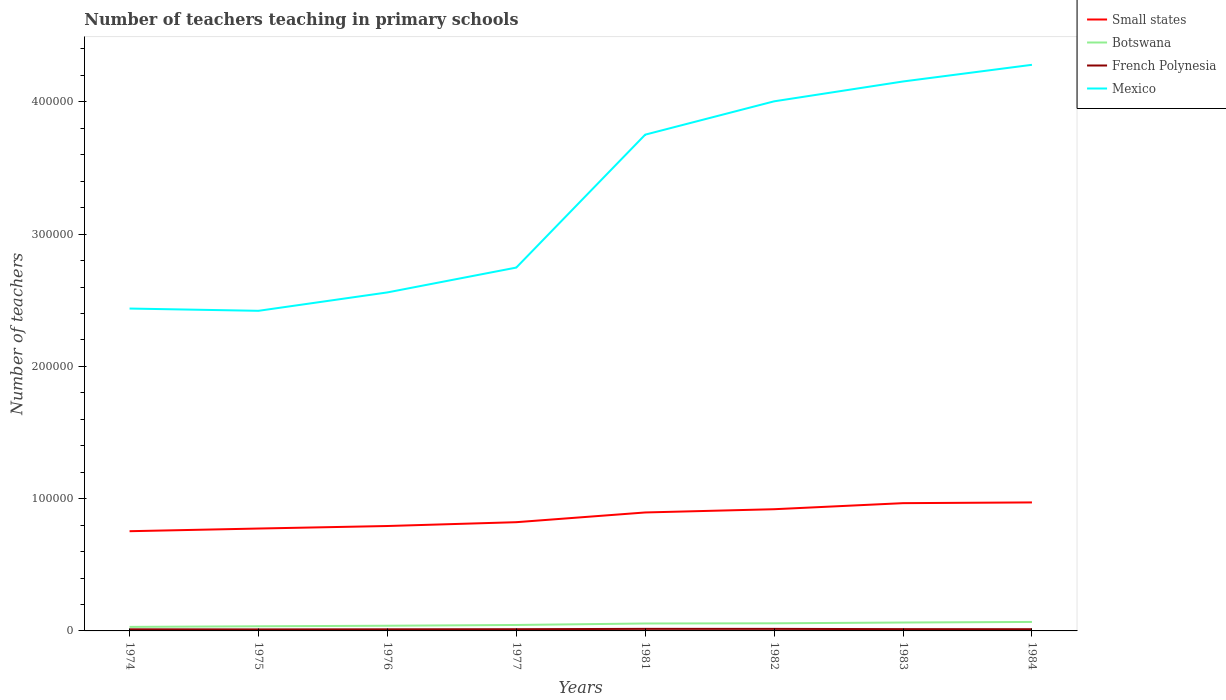How many different coloured lines are there?
Keep it short and to the point. 4. Does the line corresponding to Small states intersect with the line corresponding to Botswana?
Ensure brevity in your answer.  No. Is the number of lines equal to the number of legend labels?
Your answer should be compact. Yes. Across all years, what is the maximum number of teachers teaching in primary schools in Botswana?
Ensure brevity in your answer.  3047. In which year was the number of teachers teaching in primary schools in Mexico maximum?
Make the answer very short. 1975. What is the total number of teachers teaching in primary schools in Botswana in the graph?
Keep it short and to the point. -3285. What is the difference between the highest and the second highest number of teachers teaching in primary schools in Botswana?
Offer a terse response. 3747. What is the difference between the highest and the lowest number of teachers teaching in primary schools in Botswana?
Give a very brief answer. 4. Is the number of teachers teaching in primary schools in Small states strictly greater than the number of teachers teaching in primary schools in Mexico over the years?
Give a very brief answer. Yes. How many lines are there?
Give a very brief answer. 4. How are the legend labels stacked?
Offer a terse response. Vertical. What is the title of the graph?
Offer a very short reply. Number of teachers teaching in primary schools. Does "Cuba" appear as one of the legend labels in the graph?
Offer a terse response. No. What is the label or title of the Y-axis?
Ensure brevity in your answer.  Number of teachers. What is the Number of teachers of Small states in 1974?
Your answer should be very brief. 7.54e+04. What is the Number of teachers of Botswana in 1974?
Keep it short and to the point. 3047. What is the Number of teachers in French Polynesia in 1974?
Provide a succinct answer. 1213. What is the Number of teachers of Mexico in 1974?
Provide a short and direct response. 2.44e+05. What is the Number of teachers of Small states in 1975?
Offer a terse response. 7.74e+04. What is the Number of teachers of Botswana in 1975?
Provide a short and direct response. 3509. What is the Number of teachers of French Polynesia in 1975?
Offer a terse response. 1149. What is the Number of teachers of Mexico in 1975?
Provide a succinct answer. 2.42e+05. What is the Number of teachers in Small states in 1976?
Provide a short and direct response. 7.93e+04. What is the Number of teachers of Botswana in 1976?
Provide a succinct answer. 3921. What is the Number of teachers in French Polynesia in 1976?
Ensure brevity in your answer.  1213. What is the Number of teachers of Mexico in 1976?
Offer a terse response. 2.56e+05. What is the Number of teachers of Small states in 1977?
Offer a terse response. 8.22e+04. What is the Number of teachers in Botswana in 1977?
Offer a very short reply. 4495. What is the Number of teachers of French Polynesia in 1977?
Offer a terse response. 1295. What is the Number of teachers of Mexico in 1977?
Provide a succinct answer. 2.75e+05. What is the Number of teachers in Small states in 1981?
Keep it short and to the point. 8.96e+04. What is the Number of teachers of Botswana in 1981?
Your response must be concise. 5628. What is the Number of teachers of French Polynesia in 1981?
Provide a succinct answer. 1556. What is the Number of teachers in Mexico in 1981?
Your answer should be compact. 3.75e+05. What is the Number of teachers of Small states in 1982?
Keep it short and to the point. 9.20e+04. What is the Number of teachers in Botswana in 1982?
Offer a terse response. 5767. What is the Number of teachers in French Polynesia in 1982?
Keep it short and to the point. 1544. What is the Number of teachers of Mexico in 1982?
Offer a terse response. 4.00e+05. What is the Number of teachers of Small states in 1983?
Keep it short and to the point. 9.66e+04. What is the Number of teachers of Botswana in 1983?
Offer a very short reply. 6360. What is the Number of teachers of French Polynesia in 1983?
Your answer should be compact. 1361. What is the Number of teachers in Mexico in 1983?
Your answer should be compact. 4.15e+05. What is the Number of teachers in Small states in 1984?
Offer a very short reply. 9.72e+04. What is the Number of teachers in Botswana in 1984?
Your answer should be very brief. 6794. What is the Number of teachers of French Polynesia in 1984?
Your answer should be compact. 1295. What is the Number of teachers in Mexico in 1984?
Your response must be concise. 4.28e+05. Across all years, what is the maximum Number of teachers of Small states?
Your answer should be very brief. 9.72e+04. Across all years, what is the maximum Number of teachers of Botswana?
Ensure brevity in your answer.  6794. Across all years, what is the maximum Number of teachers in French Polynesia?
Give a very brief answer. 1556. Across all years, what is the maximum Number of teachers of Mexico?
Offer a very short reply. 4.28e+05. Across all years, what is the minimum Number of teachers in Small states?
Provide a succinct answer. 7.54e+04. Across all years, what is the minimum Number of teachers in Botswana?
Offer a terse response. 3047. Across all years, what is the minimum Number of teachers of French Polynesia?
Your response must be concise. 1149. Across all years, what is the minimum Number of teachers in Mexico?
Keep it short and to the point. 2.42e+05. What is the total Number of teachers of Small states in the graph?
Give a very brief answer. 6.90e+05. What is the total Number of teachers of Botswana in the graph?
Keep it short and to the point. 3.95e+04. What is the total Number of teachers in French Polynesia in the graph?
Your response must be concise. 1.06e+04. What is the total Number of teachers of Mexico in the graph?
Your response must be concise. 2.64e+06. What is the difference between the Number of teachers in Small states in 1974 and that in 1975?
Provide a succinct answer. -2020.26. What is the difference between the Number of teachers of Botswana in 1974 and that in 1975?
Your answer should be compact. -462. What is the difference between the Number of teachers in French Polynesia in 1974 and that in 1975?
Your answer should be very brief. 64. What is the difference between the Number of teachers of Mexico in 1974 and that in 1975?
Give a very brief answer. 1706. What is the difference between the Number of teachers of Small states in 1974 and that in 1976?
Provide a succinct answer. -3926.93. What is the difference between the Number of teachers of Botswana in 1974 and that in 1976?
Provide a succinct answer. -874. What is the difference between the Number of teachers in French Polynesia in 1974 and that in 1976?
Your response must be concise. 0. What is the difference between the Number of teachers of Mexico in 1974 and that in 1976?
Provide a short and direct response. -1.22e+04. What is the difference between the Number of teachers of Small states in 1974 and that in 1977?
Offer a very short reply. -6812.93. What is the difference between the Number of teachers of Botswana in 1974 and that in 1977?
Your answer should be very brief. -1448. What is the difference between the Number of teachers in French Polynesia in 1974 and that in 1977?
Your answer should be very brief. -82. What is the difference between the Number of teachers in Mexico in 1974 and that in 1977?
Make the answer very short. -3.10e+04. What is the difference between the Number of teachers of Small states in 1974 and that in 1981?
Your answer should be compact. -1.42e+04. What is the difference between the Number of teachers of Botswana in 1974 and that in 1981?
Offer a terse response. -2581. What is the difference between the Number of teachers of French Polynesia in 1974 and that in 1981?
Make the answer very short. -343. What is the difference between the Number of teachers in Mexico in 1974 and that in 1981?
Keep it short and to the point. -1.31e+05. What is the difference between the Number of teachers in Small states in 1974 and that in 1982?
Provide a short and direct response. -1.66e+04. What is the difference between the Number of teachers in Botswana in 1974 and that in 1982?
Offer a terse response. -2720. What is the difference between the Number of teachers of French Polynesia in 1974 and that in 1982?
Your response must be concise. -331. What is the difference between the Number of teachers of Mexico in 1974 and that in 1982?
Your answer should be very brief. -1.57e+05. What is the difference between the Number of teachers in Small states in 1974 and that in 1983?
Your answer should be compact. -2.12e+04. What is the difference between the Number of teachers of Botswana in 1974 and that in 1983?
Offer a terse response. -3313. What is the difference between the Number of teachers in French Polynesia in 1974 and that in 1983?
Ensure brevity in your answer.  -148. What is the difference between the Number of teachers in Mexico in 1974 and that in 1983?
Give a very brief answer. -1.72e+05. What is the difference between the Number of teachers of Small states in 1974 and that in 1984?
Give a very brief answer. -2.18e+04. What is the difference between the Number of teachers in Botswana in 1974 and that in 1984?
Provide a short and direct response. -3747. What is the difference between the Number of teachers of French Polynesia in 1974 and that in 1984?
Give a very brief answer. -82. What is the difference between the Number of teachers in Mexico in 1974 and that in 1984?
Ensure brevity in your answer.  -1.84e+05. What is the difference between the Number of teachers of Small states in 1975 and that in 1976?
Offer a terse response. -1906.67. What is the difference between the Number of teachers in Botswana in 1975 and that in 1976?
Ensure brevity in your answer.  -412. What is the difference between the Number of teachers of French Polynesia in 1975 and that in 1976?
Offer a terse response. -64. What is the difference between the Number of teachers in Mexico in 1975 and that in 1976?
Your answer should be very brief. -1.39e+04. What is the difference between the Number of teachers in Small states in 1975 and that in 1977?
Keep it short and to the point. -4792.67. What is the difference between the Number of teachers of Botswana in 1975 and that in 1977?
Your answer should be very brief. -986. What is the difference between the Number of teachers in French Polynesia in 1975 and that in 1977?
Your answer should be very brief. -146. What is the difference between the Number of teachers in Mexico in 1975 and that in 1977?
Ensure brevity in your answer.  -3.27e+04. What is the difference between the Number of teachers in Small states in 1975 and that in 1981?
Offer a terse response. -1.21e+04. What is the difference between the Number of teachers in Botswana in 1975 and that in 1981?
Provide a succinct answer. -2119. What is the difference between the Number of teachers in French Polynesia in 1975 and that in 1981?
Offer a very short reply. -407. What is the difference between the Number of teachers of Mexico in 1975 and that in 1981?
Offer a terse response. -1.33e+05. What is the difference between the Number of teachers of Small states in 1975 and that in 1982?
Give a very brief answer. -1.46e+04. What is the difference between the Number of teachers of Botswana in 1975 and that in 1982?
Provide a succinct answer. -2258. What is the difference between the Number of teachers in French Polynesia in 1975 and that in 1982?
Keep it short and to the point. -395. What is the difference between the Number of teachers of Mexico in 1975 and that in 1982?
Keep it short and to the point. -1.58e+05. What is the difference between the Number of teachers in Small states in 1975 and that in 1983?
Give a very brief answer. -1.92e+04. What is the difference between the Number of teachers in Botswana in 1975 and that in 1983?
Offer a terse response. -2851. What is the difference between the Number of teachers in French Polynesia in 1975 and that in 1983?
Your response must be concise. -212. What is the difference between the Number of teachers of Mexico in 1975 and that in 1983?
Your answer should be compact. -1.73e+05. What is the difference between the Number of teachers of Small states in 1975 and that in 1984?
Your response must be concise. -1.97e+04. What is the difference between the Number of teachers of Botswana in 1975 and that in 1984?
Offer a terse response. -3285. What is the difference between the Number of teachers of French Polynesia in 1975 and that in 1984?
Make the answer very short. -146. What is the difference between the Number of teachers of Mexico in 1975 and that in 1984?
Ensure brevity in your answer.  -1.86e+05. What is the difference between the Number of teachers in Small states in 1976 and that in 1977?
Provide a succinct answer. -2886. What is the difference between the Number of teachers in Botswana in 1976 and that in 1977?
Provide a succinct answer. -574. What is the difference between the Number of teachers in French Polynesia in 1976 and that in 1977?
Provide a short and direct response. -82. What is the difference between the Number of teachers of Mexico in 1976 and that in 1977?
Provide a short and direct response. -1.88e+04. What is the difference between the Number of teachers of Small states in 1976 and that in 1981?
Your response must be concise. -1.02e+04. What is the difference between the Number of teachers in Botswana in 1976 and that in 1981?
Ensure brevity in your answer.  -1707. What is the difference between the Number of teachers of French Polynesia in 1976 and that in 1981?
Provide a succinct answer. -343. What is the difference between the Number of teachers of Mexico in 1976 and that in 1981?
Provide a short and direct response. -1.19e+05. What is the difference between the Number of teachers of Small states in 1976 and that in 1982?
Offer a very short reply. -1.27e+04. What is the difference between the Number of teachers in Botswana in 1976 and that in 1982?
Offer a terse response. -1846. What is the difference between the Number of teachers of French Polynesia in 1976 and that in 1982?
Provide a short and direct response. -331. What is the difference between the Number of teachers of Mexico in 1976 and that in 1982?
Your answer should be compact. -1.44e+05. What is the difference between the Number of teachers of Small states in 1976 and that in 1983?
Keep it short and to the point. -1.73e+04. What is the difference between the Number of teachers in Botswana in 1976 and that in 1983?
Your answer should be compact. -2439. What is the difference between the Number of teachers of French Polynesia in 1976 and that in 1983?
Provide a short and direct response. -148. What is the difference between the Number of teachers in Mexico in 1976 and that in 1983?
Make the answer very short. -1.59e+05. What is the difference between the Number of teachers of Small states in 1976 and that in 1984?
Your response must be concise. -1.78e+04. What is the difference between the Number of teachers in Botswana in 1976 and that in 1984?
Offer a terse response. -2873. What is the difference between the Number of teachers in French Polynesia in 1976 and that in 1984?
Ensure brevity in your answer.  -82. What is the difference between the Number of teachers in Mexico in 1976 and that in 1984?
Keep it short and to the point. -1.72e+05. What is the difference between the Number of teachers in Small states in 1977 and that in 1981?
Ensure brevity in your answer.  -7356.84. What is the difference between the Number of teachers in Botswana in 1977 and that in 1981?
Offer a terse response. -1133. What is the difference between the Number of teachers in French Polynesia in 1977 and that in 1981?
Your response must be concise. -261. What is the difference between the Number of teachers of Mexico in 1977 and that in 1981?
Offer a terse response. -1.01e+05. What is the difference between the Number of teachers in Small states in 1977 and that in 1982?
Offer a terse response. -9806.43. What is the difference between the Number of teachers in Botswana in 1977 and that in 1982?
Provide a succinct answer. -1272. What is the difference between the Number of teachers in French Polynesia in 1977 and that in 1982?
Give a very brief answer. -249. What is the difference between the Number of teachers of Mexico in 1977 and that in 1982?
Your response must be concise. -1.26e+05. What is the difference between the Number of teachers of Small states in 1977 and that in 1983?
Make the answer very short. -1.44e+04. What is the difference between the Number of teachers in Botswana in 1977 and that in 1983?
Give a very brief answer. -1865. What is the difference between the Number of teachers of French Polynesia in 1977 and that in 1983?
Provide a short and direct response. -66. What is the difference between the Number of teachers in Mexico in 1977 and that in 1983?
Offer a very short reply. -1.41e+05. What is the difference between the Number of teachers of Small states in 1977 and that in 1984?
Give a very brief answer. -1.49e+04. What is the difference between the Number of teachers in Botswana in 1977 and that in 1984?
Offer a terse response. -2299. What is the difference between the Number of teachers in French Polynesia in 1977 and that in 1984?
Ensure brevity in your answer.  0. What is the difference between the Number of teachers of Mexico in 1977 and that in 1984?
Offer a very short reply. -1.53e+05. What is the difference between the Number of teachers of Small states in 1981 and that in 1982?
Give a very brief answer. -2449.59. What is the difference between the Number of teachers in Botswana in 1981 and that in 1982?
Provide a succinct answer. -139. What is the difference between the Number of teachers in Mexico in 1981 and that in 1982?
Your answer should be very brief. -2.52e+04. What is the difference between the Number of teachers of Small states in 1981 and that in 1983?
Give a very brief answer. -7031.91. What is the difference between the Number of teachers in Botswana in 1981 and that in 1983?
Provide a short and direct response. -732. What is the difference between the Number of teachers of French Polynesia in 1981 and that in 1983?
Keep it short and to the point. 195. What is the difference between the Number of teachers in Mexico in 1981 and that in 1983?
Make the answer very short. -4.02e+04. What is the difference between the Number of teachers in Small states in 1981 and that in 1984?
Your answer should be compact. -7590.36. What is the difference between the Number of teachers of Botswana in 1981 and that in 1984?
Your answer should be compact. -1166. What is the difference between the Number of teachers of French Polynesia in 1981 and that in 1984?
Provide a short and direct response. 261. What is the difference between the Number of teachers of Mexico in 1981 and that in 1984?
Keep it short and to the point. -5.28e+04. What is the difference between the Number of teachers in Small states in 1982 and that in 1983?
Offer a very short reply. -4582.32. What is the difference between the Number of teachers of Botswana in 1982 and that in 1983?
Keep it short and to the point. -593. What is the difference between the Number of teachers in French Polynesia in 1982 and that in 1983?
Give a very brief answer. 183. What is the difference between the Number of teachers in Mexico in 1982 and that in 1983?
Offer a very short reply. -1.50e+04. What is the difference between the Number of teachers of Small states in 1982 and that in 1984?
Offer a very short reply. -5140.77. What is the difference between the Number of teachers of Botswana in 1982 and that in 1984?
Your answer should be very brief. -1027. What is the difference between the Number of teachers of French Polynesia in 1982 and that in 1984?
Keep it short and to the point. 249. What is the difference between the Number of teachers in Mexico in 1982 and that in 1984?
Your answer should be compact. -2.76e+04. What is the difference between the Number of teachers in Small states in 1983 and that in 1984?
Provide a succinct answer. -558.45. What is the difference between the Number of teachers in Botswana in 1983 and that in 1984?
Offer a terse response. -434. What is the difference between the Number of teachers in French Polynesia in 1983 and that in 1984?
Your response must be concise. 66. What is the difference between the Number of teachers in Mexico in 1983 and that in 1984?
Provide a short and direct response. -1.26e+04. What is the difference between the Number of teachers in Small states in 1974 and the Number of teachers in Botswana in 1975?
Offer a very short reply. 7.19e+04. What is the difference between the Number of teachers in Small states in 1974 and the Number of teachers in French Polynesia in 1975?
Keep it short and to the point. 7.42e+04. What is the difference between the Number of teachers in Small states in 1974 and the Number of teachers in Mexico in 1975?
Give a very brief answer. -1.67e+05. What is the difference between the Number of teachers in Botswana in 1974 and the Number of teachers in French Polynesia in 1975?
Your answer should be very brief. 1898. What is the difference between the Number of teachers of Botswana in 1974 and the Number of teachers of Mexico in 1975?
Give a very brief answer. -2.39e+05. What is the difference between the Number of teachers of French Polynesia in 1974 and the Number of teachers of Mexico in 1975?
Provide a short and direct response. -2.41e+05. What is the difference between the Number of teachers in Small states in 1974 and the Number of teachers in Botswana in 1976?
Give a very brief answer. 7.15e+04. What is the difference between the Number of teachers of Small states in 1974 and the Number of teachers of French Polynesia in 1976?
Give a very brief answer. 7.42e+04. What is the difference between the Number of teachers of Small states in 1974 and the Number of teachers of Mexico in 1976?
Your response must be concise. -1.81e+05. What is the difference between the Number of teachers in Botswana in 1974 and the Number of teachers in French Polynesia in 1976?
Give a very brief answer. 1834. What is the difference between the Number of teachers of Botswana in 1974 and the Number of teachers of Mexico in 1976?
Make the answer very short. -2.53e+05. What is the difference between the Number of teachers in French Polynesia in 1974 and the Number of teachers in Mexico in 1976?
Give a very brief answer. -2.55e+05. What is the difference between the Number of teachers of Small states in 1974 and the Number of teachers of Botswana in 1977?
Make the answer very short. 7.09e+04. What is the difference between the Number of teachers in Small states in 1974 and the Number of teachers in French Polynesia in 1977?
Ensure brevity in your answer.  7.41e+04. What is the difference between the Number of teachers in Small states in 1974 and the Number of teachers in Mexico in 1977?
Ensure brevity in your answer.  -1.99e+05. What is the difference between the Number of teachers of Botswana in 1974 and the Number of teachers of French Polynesia in 1977?
Offer a terse response. 1752. What is the difference between the Number of teachers of Botswana in 1974 and the Number of teachers of Mexico in 1977?
Your answer should be very brief. -2.72e+05. What is the difference between the Number of teachers in French Polynesia in 1974 and the Number of teachers in Mexico in 1977?
Provide a succinct answer. -2.74e+05. What is the difference between the Number of teachers in Small states in 1974 and the Number of teachers in Botswana in 1981?
Offer a very short reply. 6.98e+04. What is the difference between the Number of teachers in Small states in 1974 and the Number of teachers in French Polynesia in 1981?
Offer a very short reply. 7.38e+04. What is the difference between the Number of teachers of Small states in 1974 and the Number of teachers of Mexico in 1981?
Your answer should be compact. -3.00e+05. What is the difference between the Number of teachers of Botswana in 1974 and the Number of teachers of French Polynesia in 1981?
Provide a succinct answer. 1491. What is the difference between the Number of teachers in Botswana in 1974 and the Number of teachers in Mexico in 1981?
Provide a short and direct response. -3.72e+05. What is the difference between the Number of teachers of French Polynesia in 1974 and the Number of teachers of Mexico in 1981?
Your response must be concise. -3.74e+05. What is the difference between the Number of teachers of Small states in 1974 and the Number of teachers of Botswana in 1982?
Your response must be concise. 6.96e+04. What is the difference between the Number of teachers of Small states in 1974 and the Number of teachers of French Polynesia in 1982?
Your answer should be compact. 7.39e+04. What is the difference between the Number of teachers in Small states in 1974 and the Number of teachers in Mexico in 1982?
Keep it short and to the point. -3.25e+05. What is the difference between the Number of teachers of Botswana in 1974 and the Number of teachers of French Polynesia in 1982?
Offer a terse response. 1503. What is the difference between the Number of teachers of Botswana in 1974 and the Number of teachers of Mexico in 1982?
Provide a succinct answer. -3.97e+05. What is the difference between the Number of teachers of French Polynesia in 1974 and the Number of teachers of Mexico in 1982?
Give a very brief answer. -3.99e+05. What is the difference between the Number of teachers of Small states in 1974 and the Number of teachers of Botswana in 1983?
Your answer should be compact. 6.90e+04. What is the difference between the Number of teachers in Small states in 1974 and the Number of teachers in French Polynesia in 1983?
Your answer should be compact. 7.40e+04. What is the difference between the Number of teachers of Small states in 1974 and the Number of teachers of Mexico in 1983?
Offer a terse response. -3.40e+05. What is the difference between the Number of teachers in Botswana in 1974 and the Number of teachers in French Polynesia in 1983?
Ensure brevity in your answer.  1686. What is the difference between the Number of teachers in Botswana in 1974 and the Number of teachers in Mexico in 1983?
Keep it short and to the point. -4.12e+05. What is the difference between the Number of teachers in French Polynesia in 1974 and the Number of teachers in Mexico in 1983?
Make the answer very short. -4.14e+05. What is the difference between the Number of teachers of Small states in 1974 and the Number of teachers of Botswana in 1984?
Your response must be concise. 6.86e+04. What is the difference between the Number of teachers in Small states in 1974 and the Number of teachers in French Polynesia in 1984?
Keep it short and to the point. 7.41e+04. What is the difference between the Number of teachers of Small states in 1974 and the Number of teachers of Mexico in 1984?
Ensure brevity in your answer.  -3.53e+05. What is the difference between the Number of teachers in Botswana in 1974 and the Number of teachers in French Polynesia in 1984?
Keep it short and to the point. 1752. What is the difference between the Number of teachers of Botswana in 1974 and the Number of teachers of Mexico in 1984?
Ensure brevity in your answer.  -4.25e+05. What is the difference between the Number of teachers in French Polynesia in 1974 and the Number of teachers in Mexico in 1984?
Provide a short and direct response. -4.27e+05. What is the difference between the Number of teachers in Small states in 1975 and the Number of teachers in Botswana in 1976?
Your answer should be compact. 7.35e+04. What is the difference between the Number of teachers in Small states in 1975 and the Number of teachers in French Polynesia in 1976?
Your answer should be compact. 7.62e+04. What is the difference between the Number of teachers in Small states in 1975 and the Number of teachers in Mexico in 1976?
Make the answer very short. -1.79e+05. What is the difference between the Number of teachers in Botswana in 1975 and the Number of teachers in French Polynesia in 1976?
Ensure brevity in your answer.  2296. What is the difference between the Number of teachers of Botswana in 1975 and the Number of teachers of Mexico in 1976?
Make the answer very short. -2.52e+05. What is the difference between the Number of teachers of French Polynesia in 1975 and the Number of teachers of Mexico in 1976?
Keep it short and to the point. -2.55e+05. What is the difference between the Number of teachers of Small states in 1975 and the Number of teachers of Botswana in 1977?
Offer a terse response. 7.29e+04. What is the difference between the Number of teachers in Small states in 1975 and the Number of teachers in French Polynesia in 1977?
Your response must be concise. 7.61e+04. What is the difference between the Number of teachers of Small states in 1975 and the Number of teachers of Mexico in 1977?
Offer a terse response. -1.97e+05. What is the difference between the Number of teachers of Botswana in 1975 and the Number of teachers of French Polynesia in 1977?
Your answer should be very brief. 2214. What is the difference between the Number of teachers of Botswana in 1975 and the Number of teachers of Mexico in 1977?
Make the answer very short. -2.71e+05. What is the difference between the Number of teachers of French Polynesia in 1975 and the Number of teachers of Mexico in 1977?
Ensure brevity in your answer.  -2.74e+05. What is the difference between the Number of teachers of Small states in 1975 and the Number of teachers of Botswana in 1981?
Offer a very short reply. 7.18e+04. What is the difference between the Number of teachers in Small states in 1975 and the Number of teachers in French Polynesia in 1981?
Your answer should be very brief. 7.59e+04. What is the difference between the Number of teachers in Small states in 1975 and the Number of teachers in Mexico in 1981?
Provide a succinct answer. -2.98e+05. What is the difference between the Number of teachers of Botswana in 1975 and the Number of teachers of French Polynesia in 1981?
Your answer should be very brief. 1953. What is the difference between the Number of teachers of Botswana in 1975 and the Number of teachers of Mexico in 1981?
Your answer should be compact. -3.72e+05. What is the difference between the Number of teachers of French Polynesia in 1975 and the Number of teachers of Mexico in 1981?
Your answer should be very brief. -3.74e+05. What is the difference between the Number of teachers of Small states in 1975 and the Number of teachers of Botswana in 1982?
Keep it short and to the point. 7.16e+04. What is the difference between the Number of teachers of Small states in 1975 and the Number of teachers of French Polynesia in 1982?
Your answer should be very brief. 7.59e+04. What is the difference between the Number of teachers in Small states in 1975 and the Number of teachers in Mexico in 1982?
Offer a very short reply. -3.23e+05. What is the difference between the Number of teachers of Botswana in 1975 and the Number of teachers of French Polynesia in 1982?
Provide a short and direct response. 1965. What is the difference between the Number of teachers of Botswana in 1975 and the Number of teachers of Mexico in 1982?
Offer a terse response. -3.97e+05. What is the difference between the Number of teachers of French Polynesia in 1975 and the Number of teachers of Mexico in 1982?
Your answer should be very brief. -3.99e+05. What is the difference between the Number of teachers of Small states in 1975 and the Number of teachers of Botswana in 1983?
Provide a short and direct response. 7.11e+04. What is the difference between the Number of teachers in Small states in 1975 and the Number of teachers in French Polynesia in 1983?
Make the answer very short. 7.61e+04. What is the difference between the Number of teachers of Small states in 1975 and the Number of teachers of Mexico in 1983?
Your response must be concise. -3.38e+05. What is the difference between the Number of teachers in Botswana in 1975 and the Number of teachers in French Polynesia in 1983?
Keep it short and to the point. 2148. What is the difference between the Number of teachers of Botswana in 1975 and the Number of teachers of Mexico in 1983?
Give a very brief answer. -4.12e+05. What is the difference between the Number of teachers in French Polynesia in 1975 and the Number of teachers in Mexico in 1983?
Keep it short and to the point. -4.14e+05. What is the difference between the Number of teachers of Small states in 1975 and the Number of teachers of Botswana in 1984?
Give a very brief answer. 7.06e+04. What is the difference between the Number of teachers of Small states in 1975 and the Number of teachers of French Polynesia in 1984?
Offer a terse response. 7.61e+04. What is the difference between the Number of teachers in Small states in 1975 and the Number of teachers in Mexico in 1984?
Offer a very short reply. -3.51e+05. What is the difference between the Number of teachers in Botswana in 1975 and the Number of teachers in French Polynesia in 1984?
Provide a short and direct response. 2214. What is the difference between the Number of teachers of Botswana in 1975 and the Number of teachers of Mexico in 1984?
Offer a very short reply. -4.25e+05. What is the difference between the Number of teachers of French Polynesia in 1975 and the Number of teachers of Mexico in 1984?
Offer a terse response. -4.27e+05. What is the difference between the Number of teachers of Small states in 1976 and the Number of teachers of Botswana in 1977?
Your answer should be very brief. 7.48e+04. What is the difference between the Number of teachers in Small states in 1976 and the Number of teachers in French Polynesia in 1977?
Offer a terse response. 7.80e+04. What is the difference between the Number of teachers in Small states in 1976 and the Number of teachers in Mexico in 1977?
Make the answer very short. -1.95e+05. What is the difference between the Number of teachers in Botswana in 1976 and the Number of teachers in French Polynesia in 1977?
Your response must be concise. 2626. What is the difference between the Number of teachers of Botswana in 1976 and the Number of teachers of Mexico in 1977?
Provide a short and direct response. -2.71e+05. What is the difference between the Number of teachers of French Polynesia in 1976 and the Number of teachers of Mexico in 1977?
Provide a short and direct response. -2.74e+05. What is the difference between the Number of teachers of Small states in 1976 and the Number of teachers of Botswana in 1981?
Provide a short and direct response. 7.37e+04. What is the difference between the Number of teachers in Small states in 1976 and the Number of teachers in French Polynesia in 1981?
Ensure brevity in your answer.  7.78e+04. What is the difference between the Number of teachers in Small states in 1976 and the Number of teachers in Mexico in 1981?
Keep it short and to the point. -2.96e+05. What is the difference between the Number of teachers of Botswana in 1976 and the Number of teachers of French Polynesia in 1981?
Your answer should be compact. 2365. What is the difference between the Number of teachers in Botswana in 1976 and the Number of teachers in Mexico in 1981?
Provide a succinct answer. -3.71e+05. What is the difference between the Number of teachers in French Polynesia in 1976 and the Number of teachers in Mexico in 1981?
Give a very brief answer. -3.74e+05. What is the difference between the Number of teachers of Small states in 1976 and the Number of teachers of Botswana in 1982?
Your response must be concise. 7.36e+04. What is the difference between the Number of teachers of Small states in 1976 and the Number of teachers of French Polynesia in 1982?
Offer a very short reply. 7.78e+04. What is the difference between the Number of teachers of Small states in 1976 and the Number of teachers of Mexico in 1982?
Offer a terse response. -3.21e+05. What is the difference between the Number of teachers in Botswana in 1976 and the Number of teachers in French Polynesia in 1982?
Your response must be concise. 2377. What is the difference between the Number of teachers in Botswana in 1976 and the Number of teachers in Mexico in 1982?
Offer a very short reply. -3.96e+05. What is the difference between the Number of teachers in French Polynesia in 1976 and the Number of teachers in Mexico in 1982?
Provide a short and direct response. -3.99e+05. What is the difference between the Number of teachers in Small states in 1976 and the Number of teachers in Botswana in 1983?
Give a very brief answer. 7.30e+04. What is the difference between the Number of teachers in Small states in 1976 and the Number of teachers in French Polynesia in 1983?
Give a very brief answer. 7.80e+04. What is the difference between the Number of teachers in Small states in 1976 and the Number of teachers in Mexico in 1983?
Your answer should be very brief. -3.36e+05. What is the difference between the Number of teachers in Botswana in 1976 and the Number of teachers in French Polynesia in 1983?
Offer a terse response. 2560. What is the difference between the Number of teachers in Botswana in 1976 and the Number of teachers in Mexico in 1983?
Your answer should be compact. -4.12e+05. What is the difference between the Number of teachers in French Polynesia in 1976 and the Number of teachers in Mexico in 1983?
Provide a short and direct response. -4.14e+05. What is the difference between the Number of teachers of Small states in 1976 and the Number of teachers of Botswana in 1984?
Provide a short and direct response. 7.25e+04. What is the difference between the Number of teachers in Small states in 1976 and the Number of teachers in French Polynesia in 1984?
Give a very brief answer. 7.80e+04. What is the difference between the Number of teachers in Small states in 1976 and the Number of teachers in Mexico in 1984?
Your response must be concise. -3.49e+05. What is the difference between the Number of teachers of Botswana in 1976 and the Number of teachers of French Polynesia in 1984?
Your answer should be compact. 2626. What is the difference between the Number of teachers in Botswana in 1976 and the Number of teachers in Mexico in 1984?
Offer a very short reply. -4.24e+05. What is the difference between the Number of teachers of French Polynesia in 1976 and the Number of teachers of Mexico in 1984?
Make the answer very short. -4.27e+05. What is the difference between the Number of teachers of Small states in 1977 and the Number of teachers of Botswana in 1981?
Keep it short and to the point. 7.66e+04. What is the difference between the Number of teachers in Small states in 1977 and the Number of teachers in French Polynesia in 1981?
Give a very brief answer. 8.07e+04. What is the difference between the Number of teachers of Small states in 1977 and the Number of teachers of Mexico in 1981?
Offer a very short reply. -2.93e+05. What is the difference between the Number of teachers of Botswana in 1977 and the Number of teachers of French Polynesia in 1981?
Your response must be concise. 2939. What is the difference between the Number of teachers in Botswana in 1977 and the Number of teachers in Mexico in 1981?
Keep it short and to the point. -3.71e+05. What is the difference between the Number of teachers of French Polynesia in 1977 and the Number of teachers of Mexico in 1981?
Ensure brevity in your answer.  -3.74e+05. What is the difference between the Number of teachers in Small states in 1977 and the Number of teachers in Botswana in 1982?
Your answer should be compact. 7.64e+04. What is the difference between the Number of teachers in Small states in 1977 and the Number of teachers in French Polynesia in 1982?
Make the answer very short. 8.07e+04. What is the difference between the Number of teachers of Small states in 1977 and the Number of teachers of Mexico in 1982?
Ensure brevity in your answer.  -3.18e+05. What is the difference between the Number of teachers of Botswana in 1977 and the Number of teachers of French Polynesia in 1982?
Provide a succinct answer. 2951. What is the difference between the Number of teachers in Botswana in 1977 and the Number of teachers in Mexico in 1982?
Provide a succinct answer. -3.96e+05. What is the difference between the Number of teachers in French Polynesia in 1977 and the Number of teachers in Mexico in 1982?
Your answer should be very brief. -3.99e+05. What is the difference between the Number of teachers of Small states in 1977 and the Number of teachers of Botswana in 1983?
Your answer should be very brief. 7.58e+04. What is the difference between the Number of teachers of Small states in 1977 and the Number of teachers of French Polynesia in 1983?
Provide a succinct answer. 8.08e+04. What is the difference between the Number of teachers of Small states in 1977 and the Number of teachers of Mexico in 1983?
Your response must be concise. -3.33e+05. What is the difference between the Number of teachers of Botswana in 1977 and the Number of teachers of French Polynesia in 1983?
Keep it short and to the point. 3134. What is the difference between the Number of teachers in Botswana in 1977 and the Number of teachers in Mexico in 1983?
Your response must be concise. -4.11e+05. What is the difference between the Number of teachers in French Polynesia in 1977 and the Number of teachers in Mexico in 1983?
Keep it short and to the point. -4.14e+05. What is the difference between the Number of teachers of Small states in 1977 and the Number of teachers of Botswana in 1984?
Offer a very short reply. 7.54e+04. What is the difference between the Number of teachers of Small states in 1977 and the Number of teachers of French Polynesia in 1984?
Provide a short and direct response. 8.09e+04. What is the difference between the Number of teachers in Small states in 1977 and the Number of teachers in Mexico in 1984?
Your answer should be very brief. -3.46e+05. What is the difference between the Number of teachers of Botswana in 1977 and the Number of teachers of French Polynesia in 1984?
Your response must be concise. 3200. What is the difference between the Number of teachers of Botswana in 1977 and the Number of teachers of Mexico in 1984?
Your answer should be compact. -4.24e+05. What is the difference between the Number of teachers in French Polynesia in 1977 and the Number of teachers in Mexico in 1984?
Keep it short and to the point. -4.27e+05. What is the difference between the Number of teachers in Small states in 1981 and the Number of teachers in Botswana in 1982?
Offer a very short reply. 8.38e+04. What is the difference between the Number of teachers of Small states in 1981 and the Number of teachers of French Polynesia in 1982?
Your response must be concise. 8.80e+04. What is the difference between the Number of teachers in Small states in 1981 and the Number of teachers in Mexico in 1982?
Provide a short and direct response. -3.11e+05. What is the difference between the Number of teachers of Botswana in 1981 and the Number of teachers of French Polynesia in 1982?
Your answer should be compact. 4084. What is the difference between the Number of teachers of Botswana in 1981 and the Number of teachers of Mexico in 1982?
Keep it short and to the point. -3.95e+05. What is the difference between the Number of teachers of French Polynesia in 1981 and the Number of teachers of Mexico in 1982?
Offer a terse response. -3.99e+05. What is the difference between the Number of teachers in Small states in 1981 and the Number of teachers in Botswana in 1983?
Make the answer very short. 8.32e+04. What is the difference between the Number of teachers in Small states in 1981 and the Number of teachers in French Polynesia in 1983?
Provide a short and direct response. 8.82e+04. What is the difference between the Number of teachers in Small states in 1981 and the Number of teachers in Mexico in 1983?
Provide a short and direct response. -3.26e+05. What is the difference between the Number of teachers of Botswana in 1981 and the Number of teachers of French Polynesia in 1983?
Your answer should be compact. 4267. What is the difference between the Number of teachers of Botswana in 1981 and the Number of teachers of Mexico in 1983?
Make the answer very short. -4.10e+05. What is the difference between the Number of teachers in French Polynesia in 1981 and the Number of teachers in Mexico in 1983?
Your answer should be very brief. -4.14e+05. What is the difference between the Number of teachers of Small states in 1981 and the Number of teachers of Botswana in 1984?
Give a very brief answer. 8.28e+04. What is the difference between the Number of teachers of Small states in 1981 and the Number of teachers of French Polynesia in 1984?
Provide a succinct answer. 8.83e+04. What is the difference between the Number of teachers in Small states in 1981 and the Number of teachers in Mexico in 1984?
Ensure brevity in your answer.  -3.38e+05. What is the difference between the Number of teachers in Botswana in 1981 and the Number of teachers in French Polynesia in 1984?
Your response must be concise. 4333. What is the difference between the Number of teachers in Botswana in 1981 and the Number of teachers in Mexico in 1984?
Offer a very short reply. -4.22e+05. What is the difference between the Number of teachers of French Polynesia in 1981 and the Number of teachers of Mexico in 1984?
Ensure brevity in your answer.  -4.26e+05. What is the difference between the Number of teachers in Small states in 1982 and the Number of teachers in Botswana in 1983?
Your answer should be very brief. 8.57e+04. What is the difference between the Number of teachers in Small states in 1982 and the Number of teachers in French Polynesia in 1983?
Your answer should be very brief. 9.07e+04. What is the difference between the Number of teachers of Small states in 1982 and the Number of teachers of Mexico in 1983?
Provide a succinct answer. -3.23e+05. What is the difference between the Number of teachers of Botswana in 1982 and the Number of teachers of French Polynesia in 1983?
Ensure brevity in your answer.  4406. What is the difference between the Number of teachers in Botswana in 1982 and the Number of teachers in Mexico in 1983?
Your answer should be very brief. -4.10e+05. What is the difference between the Number of teachers in French Polynesia in 1982 and the Number of teachers in Mexico in 1983?
Your answer should be very brief. -4.14e+05. What is the difference between the Number of teachers in Small states in 1982 and the Number of teachers in Botswana in 1984?
Offer a terse response. 8.52e+04. What is the difference between the Number of teachers of Small states in 1982 and the Number of teachers of French Polynesia in 1984?
Provide a succinct answer. 9.07e+04. What is the difference between the Number of teachers of Small states in 1982 and the Number of teachers of Mexico in 1984?
Your response must be concise. -3.36e+05. What is the difference between the Number of teachers of Botswana in 1982 and the Number of teachers of French Polynesia in 1984?
Provide a succinct answer. 4472. What is the difference between the Number of teachers in Botswana in 1982 and the Number of teachers in Mexico in 1984?
Your response must be concise. -4.22e+05. What is the difference between the Number of teachers in French Polynesia in 1982 and the Number of teachers in Mexico in 1984?
Your response must be concise. -4.26e+05. What is the difference between the Number of teachers in Small states in 1983 and the Number of teachers in Botswana in 1984?
Your answer should be compact. 8.98e+04. What is the difference between the Number of teachers of Small states in 1983 and the Number of teachers of French Polynesia in 1984?
Your response must be concise. 9.53e+04. What is the difference between the Number of teachers in Small states in 1983 and the Number of teachers in Mexico in 1984?
Keep it short and to the point. -3.31e+05. What is the difference between the Number of teachers in Botswana in 1983 and the Number of teachers in French Polynesia in 1984?
Make the answer very short. 5065. What is the difference between the Number of teachers in Botswana in 1983 and the Number of teachers in Mexico in 1984?
Give a very brief answer. -4.22e+05. What is the difference between the Number of teachers of French Polynesia in 1983 and the Number of teachers of Mexico in 1984?
Keep it short and to the point. -4.27e+05. What is the average Number of teachers in Small states per year?
Keep it short and to the point. 8.62e+04. What is the average Number of teachers of Botswana per year?
Your answer should be very brief. 4940.12. What is the average Number of teachers of French Polynesia per year?
Provide a short and direct response. 1328.25. What is the average Number of teachers in Mexico per year?
Your response must be concise. 3.29e+05. In the year 1974, what is the difference between the Number of teachers of Small states and Number of teachers of Botswana?
Make the answer very short. 7.23e+04. In the year 1974, what is the difference between the Number of teachers in Small states and Number of teachers in French Polynesia?
Your answer should be compact. 7.42e+04. In the year 1974, what is the difference between the Number of teachers of Small states and Number of teachers of Mexico?
Offer a very short reply. -1.68e+05. In the year 1974, what is the difference between the Number of teachers in Botswana and Number of teachers in French Polynesia?
Your response must be concise. 1834. In the year 1974, what is the difference between the Number of teachers in Botswana and Number of teachers in Mexico?
Provide a short and direct response. -2.41e+05. In the year 1974, what is the difference between the Number of teachers in French Polynesia and Number of teachers in Mexico?
Give a very brief answer. -2.43e+05. In the year 1975, what is the difference between the Number of teachers in Small states and Number of teachers in Botswana?
Ensure brevity in your answer.  7.39e+04. In the year 1975, what is the difference between the Number of teachers in Small states and Number of teachers in French Polynesia?
Provide a short and direct response. 7.63e+04. In the year 1975, what is the difference between the Number of teachers of Small states and Number of teachers of Mexico?
Offer a terse response. -1.65e+05. In the year 1975, what is the difference between the Number of teachers of Botswana and Number of teachers of French Polynesia?
Keep it short and to the point. 2360. In the year 1975, what is the difference between the Number of teachers in Botswana and Number of teachers in Mexico?
Your response must be concise. -2.39e+05. In the year 1975, what is the difference between the Number of teachers in French Polynesia and Number of teachers in Mexico?
Your answer should be compact. -2.41e+05. In the year 1976, what is the difference between the Number of teachers of Small states and Number of teachers of Botswana?
Provide a succinct answer. 7.54e+04. In the year 1976, what is the difference between the Number of teachers of Small states and Number of teachers of French Polynesia?
Offer a very short reply. 7.81e+04. In the year 1976, what is the difference between the Number of teachers of Small states and Number of teachers of Mexico?
Provide a succinct answer. -1.77e+05. In the year 1976, what is the difference between the Number of teachers of Botswana and Number of teachers of French Polynesia?
Provide a short and direct response. 2708. In the year 1976, what is the difference between the Number of teachers in Botswana and Number of teachers in Mexico?
Keep it short and to the point. -2.52e+05. In the year 1976, what is the difference between the Number of teachers in French Polynesia and Number of teachers in Mexico?
Your response must be concise. -2.55e+05. In the year 1977, what is the difference between the Number of teachers of Small states and Number of teachers of Botswana?
Ensure brevity in your answer.  7.77e+04. In the year 1977, what is the difference between the Number of teachers in Small states and Number of teachers in French Polynesia?
Give a very brief answer. 8.09e+04. In the year 1977, what is the difference between the Number of teachers of Small states and Number of teachers of Mexico?
Provide a short and direct response. -1.93e+05. In the year 1977, what is the difference between the Number of teachers of Botswana and Number of teachers of French Polynesia?
Your response must be concise. 3200. In the year 1977, what is the difference between the Number of teachers in Botswana and Number of teachers in Mexico?
Provide a succinct answer. -2.70e+05. In the year 1977, what is the difference between the Number of teachers of French Polynesia and Number of teachers of Mexico?
Make the answer very short. -2.73e+05. In the year 1981, what is the difference between the Number of teachers of Small states and Number of teachers of Botswana?
Make the answer very short. 8.39e+04. In the year 1981, what is the difference between the Number of teachers of Small states and Number of teachers of French Polynesia?
Make the answer very short. 8.80e+04. In the year 1981, what is the difference between the Number of teachers of Small states and Number of teachers of Mexico?
Your response must be concise. -2.86e+05. In the year 1981, what is the difference between the Number of teachers in Botswana and Number of teachers in French Polynesia?
Provide a short and direct response. 4072. In the year 1981, what is the difference between the Number of teachers of Botswana and Number of teachers of Mexico?
Ensure brevity in your answer.  -3.70e+05. In the year 1981, what is the difference between the Number of teachers in French Polynesia and Number of teachers in Mexico?
Offer a very short reply. -3.74e+05. In the year 1982, what is the difference between the Number of teachers of Small states and Number of teachers of Botswana?
Offer a very short reply. 8.62e+04. In the year 1982, what is the difference between the Number of teachers of Small states and Number of teachers of French Polynesia?
Ensure brevity in your answer.  9.05e+04. In the year 1982, what is the difference between the Number of teachers in Small states and Number of teachers in Mexico?
Provide a succinct answer. -3.08e+05. In the year 1982, what is the difference between the Number of teachers of Botswana and Number of teachers of French Polynesia?
Your response must be concise. 4223. In the year 1982, what is the difference between the Number of teachers in Botswana and Number of teachers in Mexico?
Your answer should be compact. -3.95e+05. In the year 1982, what is the difference between the Number of teachers in French Polynesia and Number of teachers in Mexico?
Make the answer very short. -3.99e+05. In the year 1983, what is the difference between the Number of teachers in Small states and Number of teachers in Botswana?
Make the answer very short. 9.02e+04. In the year 1983, what is the difference between the Number of teachers of Small states and Number of teachers of French Polynesia?
Your answer should be compact. 9.52e+04. In the year 1983, what is the difference between the Number of teachers in Small states and Number of teachers in Mexico?
Give a very brief answer. -3.19e+05. In the year 1983, what is the difference between the Number of teachers in Botswana and Number of teachers in French Polynesia?
Give a very brief answer. 4999. In the year 1983, what is the difference between the Number of teachers of Botswana and Number of teachers of Mexico?
Provide a succinct answer. -4.09e+05. In the year 1983, what is the difference between the Number of teachers of French Polynesia and Number of teachers of Mexico?
Your answer should be very brief. -4.14e+05. In the year 1984, what is the difference between the Number of teachers in Small states and Number of teachers in Botswana?
Keep it short and to the point. 9.04e+04. In the year 1984, what is the difference between the Number of teachers in Small states and Number of teachers in French Polynesia?
Ensure brevity in your answer.  9.59e+04. In the year 1984, what is the difference between the Number of teachers of Small states and Number of teachers of Mexico?
Keep it short and to the point. -3.31e+05. In the year 1984, what is the difference between the Number of teachers of Botswana and Number of teachers of French Polynesia?
Offer a very short reply. 5499. In the year 1984, what is the difference between the Number of teachers of Botswana and Number of teachers of Mexico?
Offer a terse response. -4.21e+05. In the year 1984, what is the difference between the Number of teachers in French Polynesia and Number of teachers in Mexico?
Ensure brevity in your answer.  -4.27e+05. What is the ratio of the Number of teachers of Small states in 1974 to that in 1975?
Provide a short and direct response. 0.97. What is the ratio of the Number of teachers in Botswana in 1974 to that in 1975?
Your answer should be compact. 0.87. What is the ratio of the Number of teachers in French Polynesia in 1974 to that in 1975?
Provide a short and direct response. 1.06. What is the ratio of the Number of teachers in Small states in 1974 to that in 1976?
Keep it short and to the point. 0.95. What is the ratio of the Number of teachers of Botswana in 1974 to that in 1976?
Keep it short and to the point. 0.78. What is the ratio of the Number of teachers in French Polynesia in 1974 to that in 1976?
Make the answer very short. 1. What is the ratio of the Number of teachers of Mexico in 1974 to that in 1976?
Provide a short and direct response. 0.95. What is the ratio of the Number of teachers in Small states in 1974 to that in 1977?
Give a very brief answer. 0.92. What is the ratio of the Number of teachers in Botswana in 1974 to that in 1977?
Offer a terse response. 0.68. What is the ratio of the Number of teachers in French Polynesia in 1974 to that in 1977?
Make the answer very short. 0.94. What is the ratio of the Number of teachers of Mexico in 1974 to that in 1977?
Your answer should be very brief. 0.89. What is the ratio of the Number of teachers of Small states in 1974 to that in 1981?
Offer a terse response. 0.84. What is the ratio of the Number of teachers in Botswana in 1974 to that in 1981?
Offer a terse response. 0.54. What is the ratio of the Number of teachers of French Polynesia in 1974 to that in 1981?
Your answer should be very brief. 0.78. What is the ratio of the Number of teachers of Mexico in 1974 to that in 1981?
Keep it short and to the point. 0.65. What is the ratio of the Number of teachers in Small states in 1974 to that in 1982?
Your answer should be very brief. 0.82. What is the ratio of the Number of teachers in Botswana in 1974 to that in 1982?
Give a very brief answer. 0.53. What is the ratio of the Number of teachers of French Polynesia in 1974 to that in 1982?
Provide a short and direct response. 0.79. What is the ratio of the Number of teachers in Mexico in 1974 to that in 1982?
Ensure brevity in your answer.  0.61. What is the ratio of the Number of teachers of Small states in 1974 to that in 1983?
Your answer should be compact. 0.78. What is the ratio of the Number of teachers of Botswana in 1974 to that in 1983?
Offer a terse response. 0.48. What is the ratio of the Number of teachers in French Polynesia in 1974 to that in 1983?
Your response must be concise. 0.89. What is the ratio of the Number of teachers of Mexico in 1974 to that in 1983?
Offer a terse response. 0.59. What is the ratio of the Number of teachers in Small states in 1974 to that in 1984?
Offer a very short reply. 0.78. What is the ratio of the Number of teachers in Botswana in 1974 to that in 1984?
Your response must be concise. 0.45. What is the ratio of the Number of teachers in French Polynesia in 1974 to that in 1984?
Offer a very short reply. 0.94. What is the ratio of the Number of teachers of Mexico in 1974 to that in 1984?
Offer a very short reply. 0.57. What is the ratio of the Number of teachers in Botswana in 1975 to that in 1976?
Ensure brevity in your answer.  0.89. What is the ratio of the Number of teachers of French Polynesia in 1975 to that in 1976?
Offer a very short reply. 0.95. What is the ratio of the Number of teachers of Mexico in 1975 to that in 1976?
Your answer should be compact. 0.95. What is the ratio of the Number of teachers of Small states in 1975 to that in 1977?
Offer a terse response. 0.94. What is the ratio of the Number of teachers in Botswana in 1975 to that in 1977?
Your answer should be very brief. 0.78. What is the ratio of the Number of teachers in French Polynesia in 1975 to that in 1977?
Your response must be concise. 0.89. What is the ratio of the Number of teachers in Mexico in 1975 to that in 1977?
Provide a short and direct response. 0.88. What is the ratio of the Number of teachers in Small states in 1975 to that in 1981?
Give a very brief answer. 0.86. What is the ratio of the Number of teachers in Botswana in 1975 to that in 1981?
Make the answer very short. 0.62. What is the ratio of the Number of teachers of French Polynesia in 1975 to that in 1981?
Your response must be concise. 0.74. What is the ratio of the Number of teachers of Mexico in 1975 to that in 1981?
Provide a succinct answer. 0.65. What is the ratio of the Number of teachers of Small states in 1975 to that in 1982?
Your answer should be very brief. 0.84. What is the ratio of the Number of teachers in Botswana in 1975 to that in 1982?
Offer a terse response. 0.61. What is the ratio of the Number of teachers of French Polynesia in 1975 to that in 1982?
Provide a short and direct response. 0.74. What is the ratio of the Number of teachers of Mexico in 1975 to that in 1982?
Your response must be concise. 0.6. What is the ratio of the Number of teachers of Small states in 1975 to that in 1983?
Provide a succinct answer. 0.8. What is the ratio of the Number of teachers in Botswana in 1975 to that in 1983?
Your response must be concise. 0.55. What is the ratio of the Number of teachers in French Polynesia in 1975 to that in 1983?
Keep it short and to the point. 0.84. What is the ratio of the Number of teachers in Mexico in 1975 to that in 1983?
Offer a very short reply. 0.58. What is the ratio of the Number of teachers of Small states in 1975 to that in 1984?
Keep it short and to the point. 0.8. What is the ratio of the Number of teachers of Botswana in 1975 to that in 1984?
Offer a terse response. 0.52. What is the ratio of the Number of teachers of French Polynesia in 1975 to that in 1984?
Offer a terse response. 0.89. What is the ratio of the Number of teachers of Mexico in 1975 to that in 1984?
Provide a succinct answer. 0.57. What is the ratio of the Number of teachers of Small states in 1976 to that in 1977?
Your answer should be compact. 0.96. What is the ratio of the Number of teachers of Botswana in 1976 to that in 1977?
Make the answer very short. 0.87. What is the ratio of the Number of teachers of French Polynesia in 1976 to that in 1977?
Provide a succinct answer. 0.94. What is the ratio of the Number of teachers of Mexico in 1976 to that in 1977?
Ensure brevity in your answer.  0.93. What is the ratio of the Number of teachers of Small states in 1976 to that in 1981?
Provide a succinct answer. 0.89. What is the ratio of the Number of teachers of Botswana in 1976 to that in 1981?
Make the answer very short. 0.7. What is the ratio of the Number of teachers of French Polynesia in 1976 to that in 1981?
Offer a very short reply. 0.78. What is the ratio of the Number of teachers in Mexico in 1976 to that in 1981?
Offer a terse response. 0.68. What is the ratio of the Number of teachers of Small states in 1976 to that in 1982?
Make the answer very short. 0.86. What is the ratio of the Number of teachers of Botswana in 1976 to that in 1982?
Your answer should be compact. 0.68. What is the ratio of the Number of teachers in French Polynesia in 1976 to that in 1982?
Provide a short and direct response. 0.79. What is the ratio of the Number of teachers of Mexico in 1976 to that in 1982?
Offer a very short reply. 0.64. What is the ratio of the Number of teachers of Small states in 1976 to that in 1983?
Your response must be concise. 0.82. What is the ratio of the Number of teachers in Botswana in 1976 to that in 1983?
Provide a succinct answer. 0.62. What is the ratio of the Number of teachers of French Polynesia in 1976 to that in 1983?
Provide a succinct answer. 0.89. What is the ratio of the Number of teachers of Mexico in 1976 to that in 1983?
Make the answer very short. 0.62. What is the ratio of the Number of teachers in Small states in 1976 to that in 1984?
Make the answer very short. 0.82. What is the ratio of the Number of teachers of Botswana in 1976 to that in 1984?
Ensure brevity in your answer.  0.58. What is the ratio of the Number of teachers of French Polynesia in 1976 to that in 1984?
Give a very brief answer. 0.94. What is the ratio of the Number of teachers in Mexico in 1976 to that in 1984?
Keep it short and to the point. 0.6. What is the ratio of the Number of teachers in Small states in 1977 to that in 1981?
Provide a short and direct response. 0.92. What is the ratio of the Number of teachers of Botswana in 1977 to that in 1981?
Ensure brevity in your answer.  0.8. What is the ratio of the Number of teachers in French Polynesia in 1977 to that in 1981?
Your answer should be compact. 0.83. What is the ratio of the Number of teachers of Mexico in 1977 to that in 1981?
Your answer should be very brief. 0.73. What is the ratio of the Number of teachers in Small states in 1977 to that in 1982?
Make the answer very short. 0.89. What is the ratio of the Number of teachers in Botswana in 1977 to that in 1982?
Your answer should be compact. 0.78. What is the ratio of the Number of teachers of French Polynesia in 1977 to that in 1982?
Your answer should be very brief. 0.84. What is the ratio of the Number of teachers of Mexico in 1977 to that in 1982?
Offer a very short reply. 0.69. What is the ratio of the Number of teachers in Small states in 1977 to that in 1983?
Your response must be concise. 0.85. What is the ratio of the Number of teachers in Botswana in 1977 to that in 1983?
Make the answer very short. 0.71. What is the ratio of the Number of teachers in French Polynesia in 1977 to that in 1983?
Make the answer very short. 0.95. What is the ratio of the Number of teachers of Mexico in 1977 to that in 1983?
Ensure brevity in your answer.  0.66. What is the ratio of the Number of teachers of Small states in 1977 to that in 1984?
Provide a short and direct response. 0.85. What is the ratio of the Number of teachers of Botswana in 1977 to that in 1984?
Your answer should be very brief. 0.66. What is the ratio of the Number of teachers of Mexico in 1977 to that in 1984?
Ensure brevity in your answer.  0.64. What is the ratio of the Number of teachers in Small states in 1981 to that in 1982?
Provide a succinct answer. 0.97. What is the ratio of the Number of teachers in Botswana in 1981 to that in 1982?
Provide a succinct answer. 0.98. What is the ratio of the Number of teachers in Mexico in 1981 to that in 1982?
Offer a terse response. 0.94. What is the ratio of the Number of teachers of Small states in 1981 to that in 1983?
Your answer should be compact. 0.93. What is the ratio of the Number of teachers in Botswana in 1981 to that in 1983?
Your answer should be compact. 0.88. What is the ratio of the Number of teachers of French Polynesia in 1981 to that in 1983?
Your answer should be compact. 1.14. What is the ratio of the Number of teachers of Mexico in 1981 to that in 1983?
Your answer should be compact. 0.9. What is the ratio of the Number of teachers of Small states in 1981 to that in 1984?
Keep it short and to the point. 0.92. What is the ratio of the Number of teachers of Botswana in 1981 to that in 1984?
Offer a very short reply. 0.83. What is the ratio of the Number of teachers of French Polynesia in 1981 to that in 1984?
Your answer should be compact. 1.2. What is the ratio of the Number of teachers in Mexico in 1981 to that in 1984?
Give a very brief answer. 0.88. What is the ratio of the Number of teachers in Small states in 1982 to that in 1983?
Provide a succinct answer. 0.95. What is the ratio of the Number of teachers of Botswana in 1982 to that in 1983?
Your answer should be very brief. 0.91. What is the ratio of the Number of teachers of French Polynesia in 1982 to that in 1983?
Give a very brief answer. 1.13. What is the ratio of the Number of teachers in Mexico in 1982 to that in 1983?
Provide a short and direct response. 0.96. What is the ratio of the Number of teachers of Small states in 1982 to that in 1984?
Your answer should be compact. 0.95. What is the ratio of the Number of teachers in Botswana in 1982 to that in 1984?
Your response must be concise. 0.85. What is the ratio of the Number of teachers of French Polynesia in 1982 to that in 1984?
Offer a very short reply. 1.19. What is the ratio of the Number of teachers of Mexico in 1982 to that in 1984?
Your answer should be very brief. 0.94. What is the ratio of the Number of teachers of Small states in 1983 to that in 1984?
Your response must be concise. 0.99. What is the ratio of the Number of teachers of Botswana in 1983 to that in 1984?
Your answer should be very brief. 0.94. What is the ratio of the Number of teachers in French Polynesia in 1983 to that in 1984?
Keep it short and to the point. 1.05. What is the ratio of the Number of teachers of Mexico in 1983 to that in 1984?
Ensure brevity in your answer.  0.97. What is the difference between the highest and the second highest Number of teachers of Small states?
Offer a very short reply. 558.45. What is the difference between the highest and the second highest Number of teachers of Botswana?
Make the answer very short. 434. What is the difference between the highest and the second highest Number of teachers in French Polynesia?
Provide a succinct answer. 12. What is the difference between the highest and the second highest Number of teachers in Mexico?
Your answer should be compact. 1.26e+04. What is the difference between the highest and the lowest Number of teachers of Small states?
Ensure brevity in your answer.  2.18e+04. What is the difference between the highest and the lowest Number of teachers of Botswana?
Ensure brevity in your answer.  3747. What is the difference between the highest and the lowest Number of teachers in French Polynesia?
Your response must be concise. 407. What is the difference between the highest and the lowest Number of teachers of Mexico?
Give a very brief answer. 1.86e+05. 